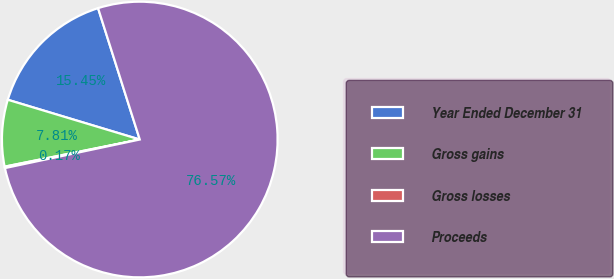Convert chart to OTSL. <chart><loc_0><loc_0><loc_500><loc_500><pie_chart><fcel>Year Ended December 31<fcel>Gross gains<fcel>Gross losses<fcel>Proceeds<nl><fcel>15.45%<fcel>7.81%<fcel>0.17%<fcel>76.56%<nl></chart> 